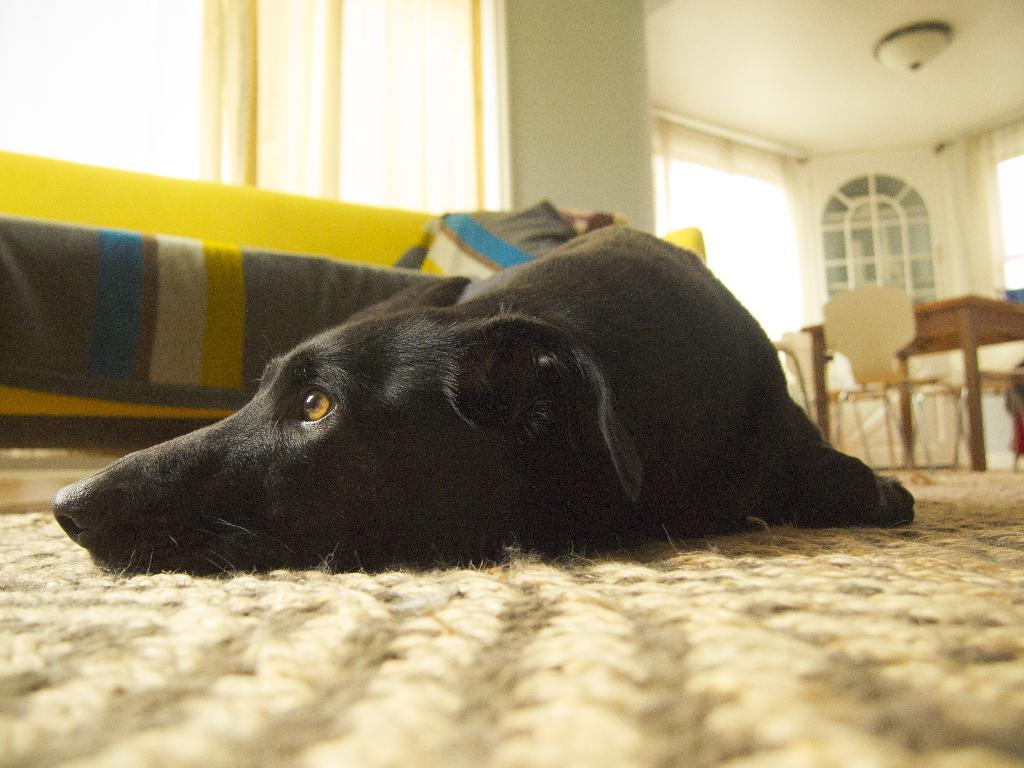What type of animal is in the image? There is a black dog in the image. What is the dog doing in the image? The dog is sleeping on the floor. What piece of furniture is near the dog? There is a yellow sofa beside the dog. What other piece of furniture is visible in the image? There is a dining table behind the dog. How many tomatoes are on the dog's head in the image? There are no tomatoes present in the image, let alone on the dog's head. 